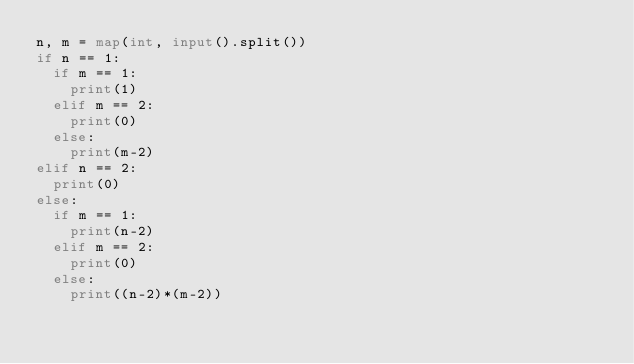<code> <loc_0><loc_0><loc_500><loc_500><_Python_>n, m = map(int, input().split())
if n == 1:
  if m == 1:
    print(1)
  elif m == 2:
    print(0)
  else:
    print(m-2)
elif n == 2:
  print(0)
else:
  if m == 1:
    print(n-2)
  elif m == 2:
    print(0)
  else:
    print((n-2)*(m-2))</code> 